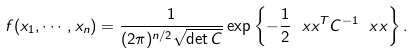<formula> <loc_0><loc_0><loc_500><loc_500>f ( x _ { 1 } , \cdots , x _ { n } ) = \frac { 1 } { ( 2 \pi ) ^ { n / 2 } \sqrt { \det C } } \exp \left \{ - \frac { 1 } { 2 } \ x x ^ { T } C ^ { - 1 } \ x x \right \} .</formula> 